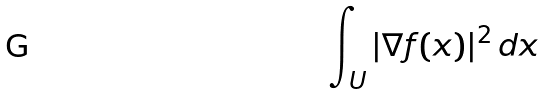<formula> <loc_0><loc_0><loc_500><loc_500>\int _ { U } | \nabla f ( x ) | ^ { 2 } \, d x</formula> 